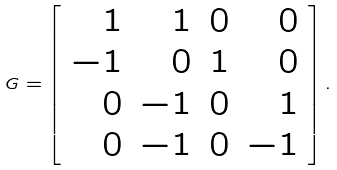Convert formula to latex. <formula><loc_0><loc_0><loc_500><loc_500>G = \left [ \begin{array} { r r r r } 1 & 1 & 0 & 0 \\ - 1 & 0 & 1 & 0 \\ 0 & - 1 & 0 & 1 \\ 0 & - 1 & 0 & - 1 \end{array} \right ] .</formula> 